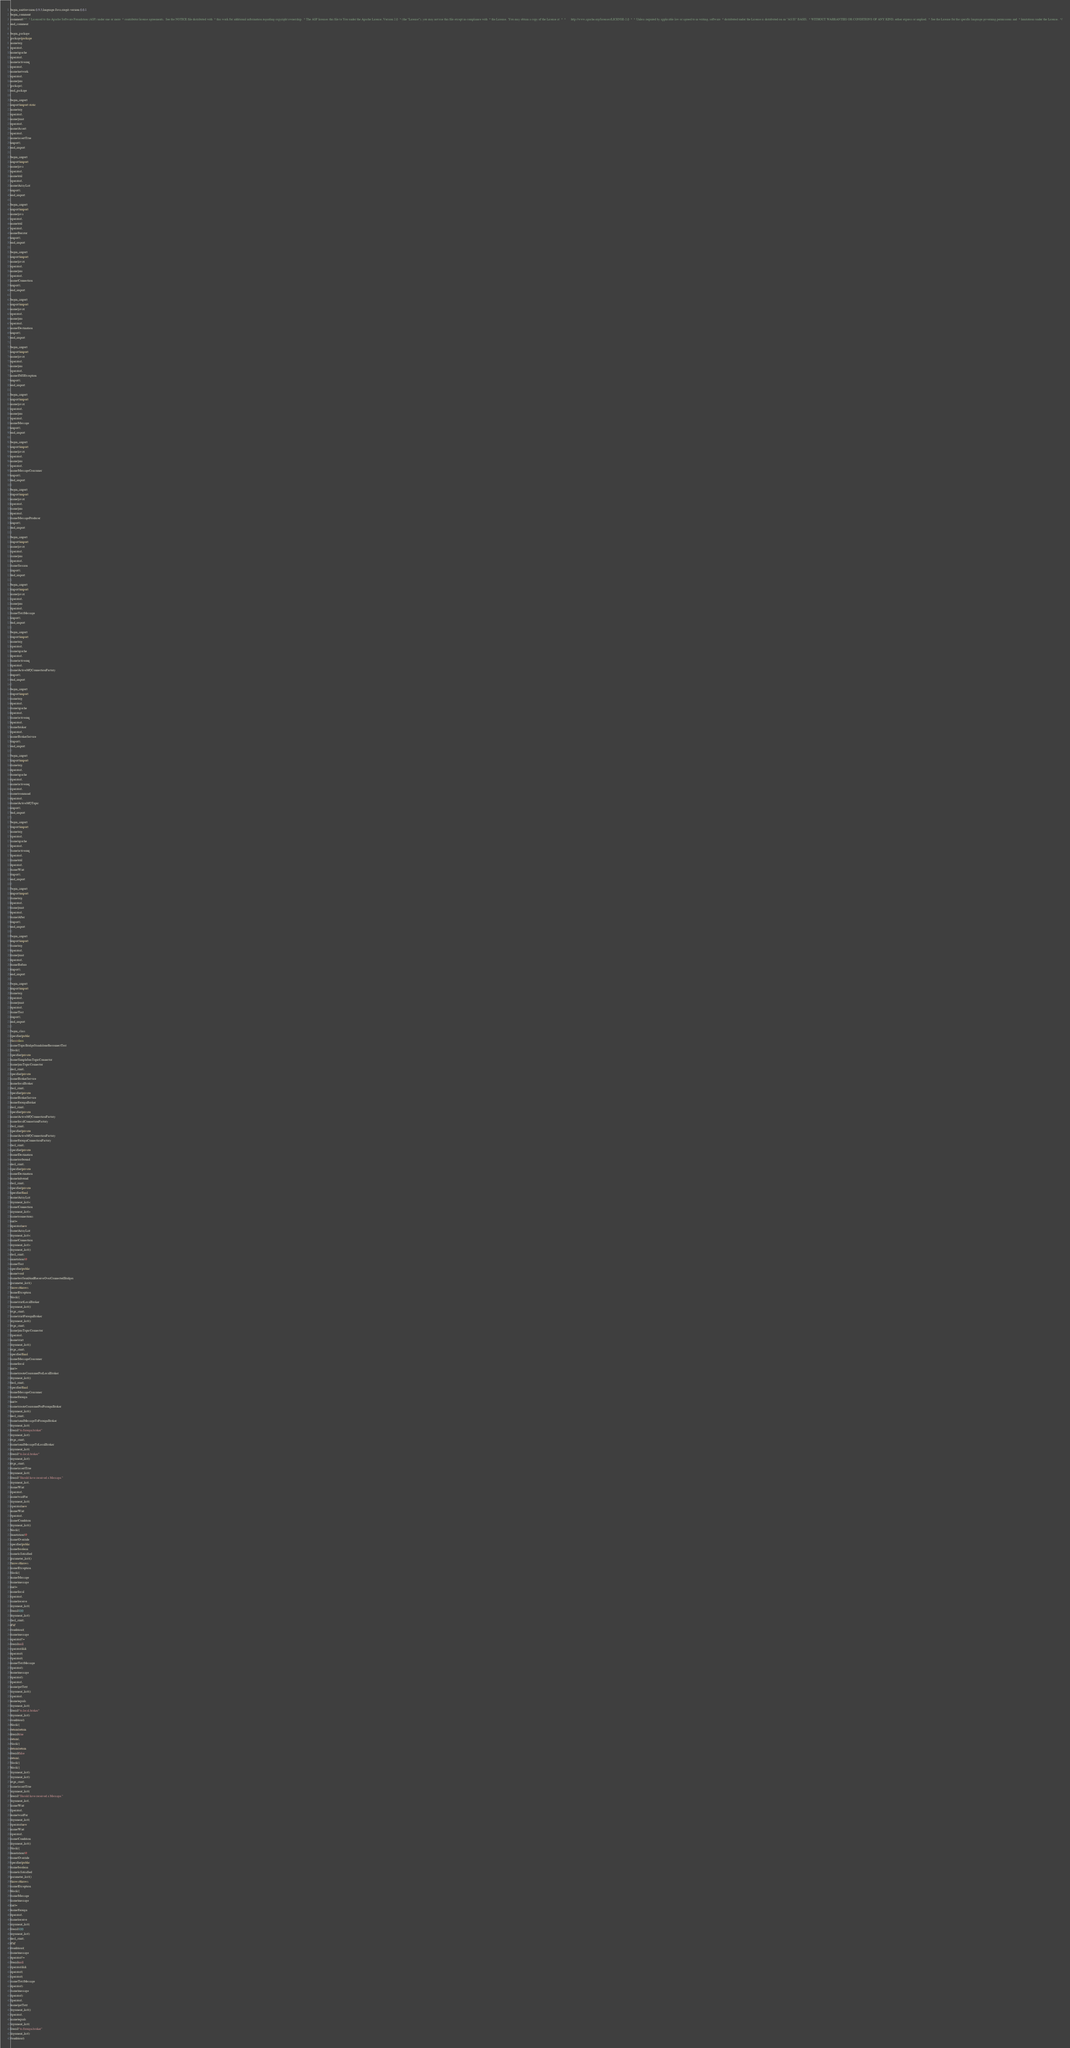<code> <loc_0><loc_0><loc_500><loc_500><_Java_>begin_unit|revision:0.9.5;language:Java;cregit-version:0.0.1
begin_comment
comment|/**  * Licensed to the Apache Software Foundation (ASF) under one or more  * contributor license agreements.  See the NOTICE file distributed with  * this work for additional information regarding copyright ownership.  * The ASF licenses this file to You under the Apache License, Version 2.0  * (the "License"); you may not use this file except in compliance with  * the License.  You may obtain a copy of the License at  *  *      http://www.apache.org/licenses/LICENSE-2.0  *  * Unless required by applicable law or agreed to in writing, software  * distributed under the License is distributed on an "AS IS" BASIS,  * WITHOUT WARRANTIES OR CONDITIONS OF ANY KIND, either express or implied.  * See the License for the specific language governing permissions and  * limitations under the License.  */
end_comment

begin_package
package|package
name|org
operator|.
name|apache
operator|.
name|activemq
operator|.
name|network
operator|.
name|jms
package|;
end_package

begin_import
import|import static
name|org
operator|.
name|junit
operator|.
name|Assert
operator|.
name|assertTrue
import|;
end_import

begin_import
import|import
name|java
operator|.
name|util
operator|.
name|ArrayList
import|;
end_import

begin_import
import|import
name|java
operator|.
name|util
operator|.
name|Iterator
import|;
end_import

begin_import
import|import
name|javax
operator|.
name|jms
operator|.
name|Connection
import|;
end_import

begin_import
import|import
name|javax
operator|.
name|jms
operator|.
name|Destination
import|;
end_import

begin_import
import|import
name|javax
operator|.
name|jms
operator|.
name|JMSException
import|;
end_import

begin_import
import|import
name|javax
operator|.
name|jms
operator|.
name|Message
import|;
end_import

begin_import
import|import
name|javax
operator|.
name|jms
operator|.
name|MessageConsumer
import|;
end_import

begin_import
import|import
name|javax
operator|.
name|jms
operator|.
name|MessageProducer
import|;
end_import

begin_import
import|import
name|javax
operator|.
name|jms
operator|.
name|Session
import|;
end_import

begin_import
import|import
name|javax
operator|.
name|jms
operator|.
name|TextMessage
import|;
end_import

begin_import
import|import
name|org
operator|.
name|apache
operator|.
name|activemq
operator|.
name|ActiveMQConnectionFactory
import|;
end_import

begin_import
import|import
name|org
operator|.
name|apache
operator|.
name|activemq
operator|.
name|broker
operator|.
name|BrokerService
import|;
end_import

begin_import
import|import
name|org
operator|.
name|apache
operator|.
name|activemq
operator|.
name|command
operator|.
name|ActiveMQTopic
import|;
end_import

begin_import
import|import
name|org
operator|.
name|apache
operator|.
name|activemq
operator|.
name|util
operator|.
name|Wait
import|;
end_import

begin_import
import|import
name|org
operator|.
name|junit
operator|.
name|After
import|;
end_import

begin_import
import|import
name|org
operator|.
name|junit
operator|.
name|Before
import|;
end_import

begin_import
import|import
name|org
operator|.
name|junit
operator|.
name|Test
import|;
end_import

begin_class
specifier|public
class|class
name|TopicBridgeStandaloneReconnectTest
block|{
specifier|private
name|SimpleJmsTopicConnector
name|jmsTopicConnector
decl_stmt|;
specifier|private
name|BrokerService
name|localBroker
decl_stmt|;
specifier|private
name|BrokerService
name|foreignBroker
decl_stmt|;
specifier|private
name|ActiveMQConnectionFactory
name|localConnectionFactory
decl_stmt|;
specifier|private
name|ActiveMQConnectionFactory
name|foreignConnectionFactory
decl_stmt|;
specifier|private
name|Destination
name|outbound
decl_stmt|;
specifier|private
name|Destination
name|inbound
decl_stmt|;
specifier|private
specifier|final
name|ArrayList
argument_list|<
name|Connection
argument_list|>
name|connections
init|=
operator|new
name|ArrayList
argument_list|<
name|Connection
argument_list|>
argument_list|()
decl_stmt|;
annotation|@
name|Test
specifier|public
name|void
name|testSendAndReceiveOverConnectedBridges
parameter_list|()
throws|throws
name|Exception
block|{
name|startLocalBroker
argument_list|()
expr_stmt|;
name|startForeignBroker
argument_list|()
expr_stmt|;
name|jmsTopicConnector
operator|.
name|start
argument_list|()
expr_stmt|;
specifier|final
name|MessageConsumer
name|local
init|=
name|createConsumerForLocalBroker
argument_list|()
decl_stmt|;
specifier|final
name|MessageConsumer
name|foreign
init|=
name|createConsumerForForeignBroker
argument_list|()
decl_stmt|;
name|sendMessageToForeignBroker
argument_list|(
literal|"to.foreign.broker"
argument_list|)
expr_stmt|;
name|sendMessageToLocalBroker
argument_list|(
literal|"to.local.broker"
argument_list|)
expr_stmt|;
name|assertTrue
argument_list|(
literal|"Should have received a Message."
argument_list|,
name|Wait
operator|.
name|waitFor
argument_list|(
operator|new
name|Wait
operator|.
name|Condition
argument_list|()
block|{
annotation|@
name|Override
specifier|public
name|boolean
name|isSatisified
parameter_list|()
throws|throws
name|Exception
block|{
name|Message
name|message
init|=
name|local
operator|.
name|receive
argument_list|(
literal|100
argument_list|)
decl_stmt|;
if|if
condition|(
name|message
operator|!=
literal|null
operator|&&
operator|(
operator|(
name|TextMessage
operator|)
name|message
operator|)
operator|.
name|getText
argument_list|()
operator|.
name|equals
argument_list|(
literal|"to.local.broker"
argument_list|)
condition|)
block|{
return|return
literal|true
return|;
block|}
return|return
literal|false
return|;
block|}
block|}
argument_list|)
argument_list|)
expr_stmt|;
name|assertTrue
argument_list|(
literal|"Should have received a Message."
argument_list|,
name|Wait
operator|.
name|waitFor
argument_list|(
operator|new
name|Wait
operator|.
name|Condition
argument_list|()
block|{
annotation|@
name|Override
specifier|public
name|boolean
name|isSatisified
parameter_list|()
throws|throws
name|Exception
block|{
name|Message
name|message
init|=
name|foreign
operator|.
name|receive
argument_list|(
literal|100
argument_list|)
decl_stmt|;
if|if
condition|(
name|message
operator|!=
literal|null
operator|&&
operator|(
operator|(
name|TextMessage
operator|)
name|message
operator|)
operator|.
name|getText
argument_list|()
operator|.
name|equals
argument_list|(
literal|"to.foreign.broker"
argument_list|)
condition|)</code> 